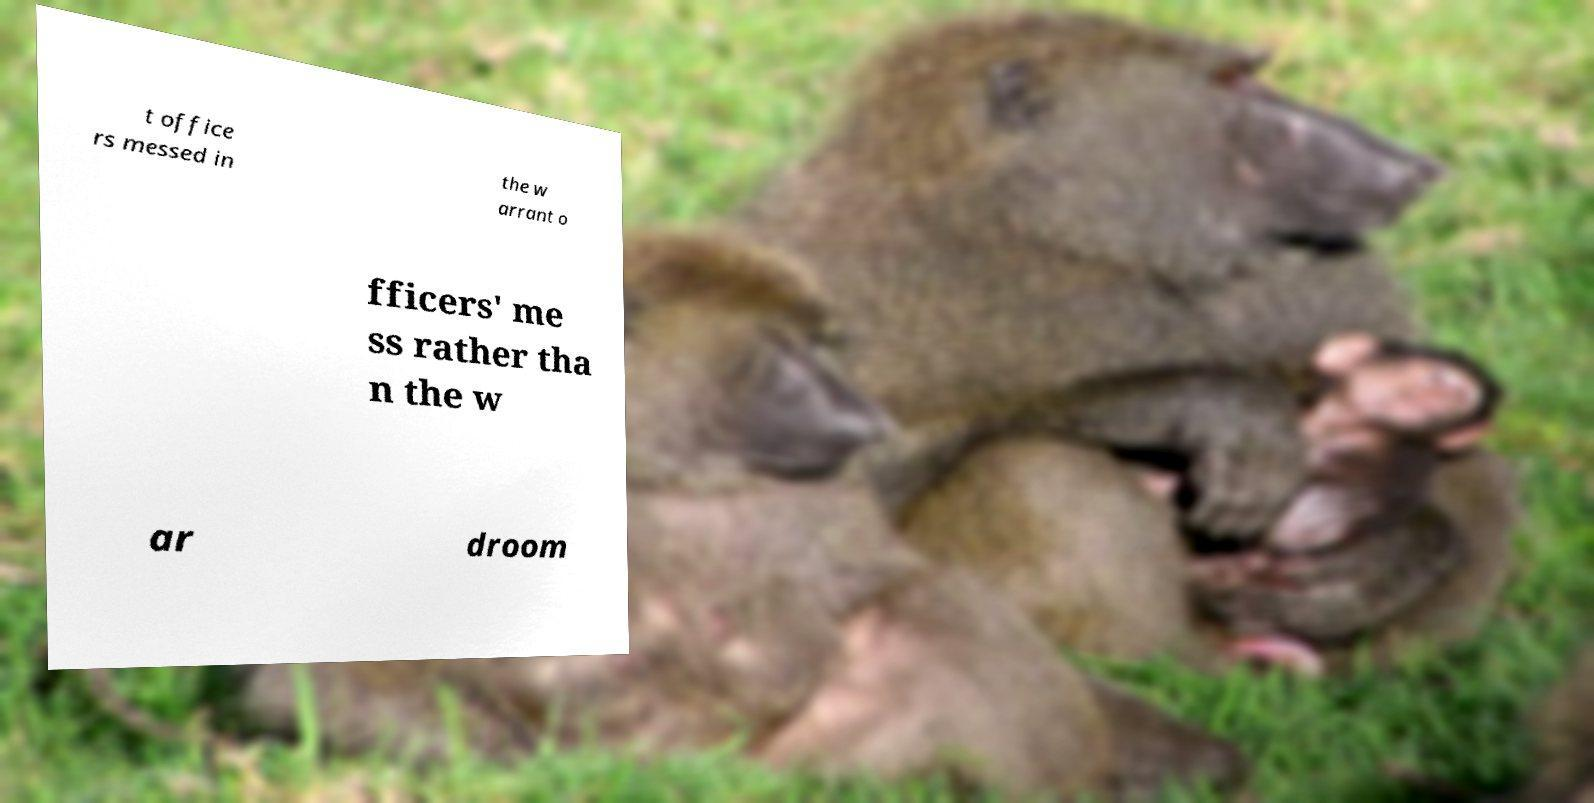Could you extract and type out the text from this image? t office rs messed in the w arrant o fficers' me ss rather tha n the w ar droom 